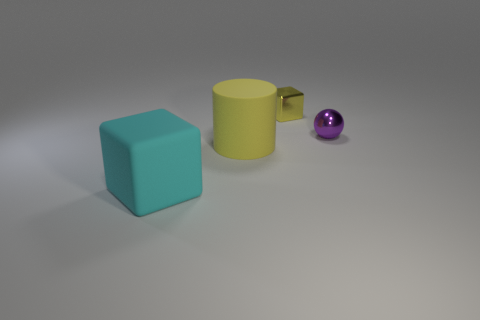Add 1 tiny purple things. How many objects exist? 5 Subtract all cylinders. How many objects are left? 3 Add 2 tiny purple shiny objects. How many tiny purple shiny objects exist? 3 Subtract 0 yellow spheres. How many objects are left? 4 Subtract all shiny things. Subtract all rubber cylinders. How many objects are left? 1 Add 4 purple metal balls. How many purple metal balls are left? 5 